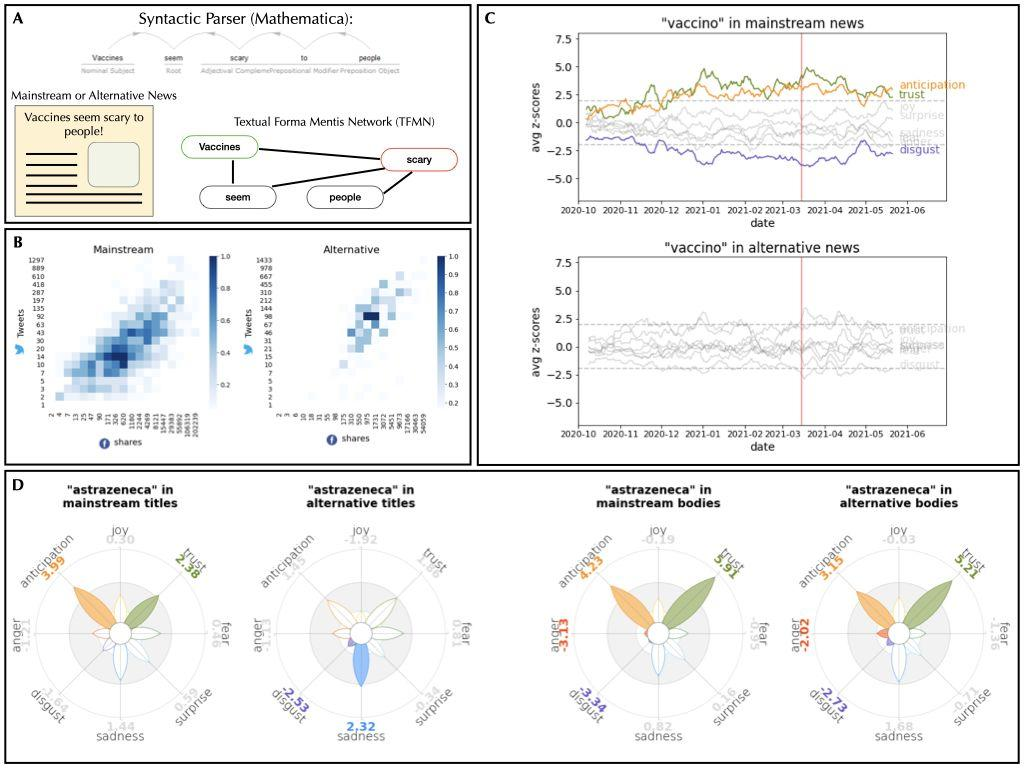What can be inferred about the distribution of the word "shares" in news articles, as shown in Figure B? The heatmaps in Figure B reveal varying distributions of the word "shares" across news types. On these maps, the x-axis likely represents the position within the article, while the y-axis indicates frequency. Notably, the heatmap for mainstream news demonstrates a more consistent spread throughout the articles, suggesting an even term usage. In contrast, the heatmap for alternative news shows the word 'shares' scattering less densely and more sporadically, indicating a concentration towards specific parts rather than a uniform spread. This behavioral insight points to differing editorial practices and focus areas between mainstream and alternative news regarding the discussed topics. 